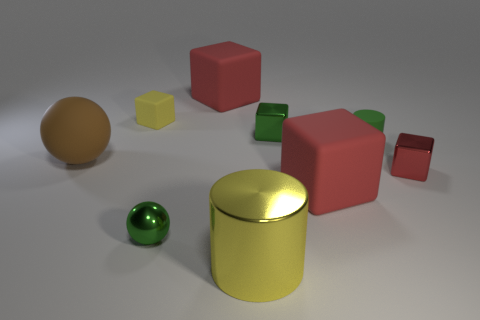Is the large cube that is behind the brown rubber sphere made of the same material as the yellow object left of the big metal object?
Ensure brevity in your answer.  Yes. What is the shape of the tiny green object that is in front of the big rubber object that is right of the big shiny thing?
Your answer should be compact. Sphere. What is the color of the sphere that is the same material as the green block?
Ensure brevity in your answer.  Green. Is the color of the large matte ball the same as the small cylinder?
Your answer should be very brief. No. There is a metallic object that is the same size as the matte ball; what shape is it?
Your answer should be compact. Cylinder. What is the size of the brown rubber ball?
Provide a succinct answer. Large. Is the size of the block behind the small yellow thing the same as the yellow metallic cylinder that is in front of the tiny green shiny cube?
Keep it short and to the point. Yes. There is a large matte block that is in front of the big rubber block that is behind the tiny green matte cylinder; what is its color?
Provide a short and direct response. Red. There is a green cube that is the same size as the metallic sphere; what is it made of?
Keep it short and to the point. Metal. How many metal objects are small cylinders or big objects?
Your response must be concise. 1. 